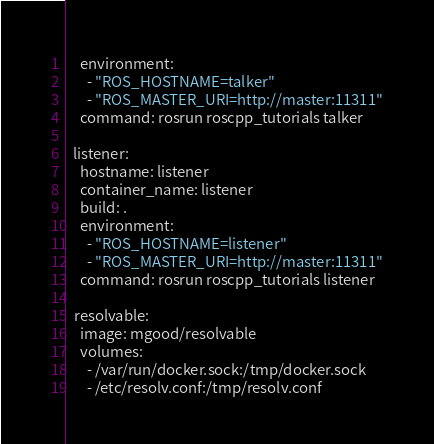Convert code to text. <code><loc_0><loc_0><loc_500><loc_500><_YAML_>    environment:
      - "ROS_HOSTNAME=talker"
      - "ROS_MASTER_URI=http://master:11311"
    command: rosrun roscpp_tutorials talker

  listener:
    hostname: listener
    container_name: listener
    build: .
    environment:
      - "ROS_HOSTNAME=listener"
      - "ROS_MASTER_URI=http://master:11311"
    command: rosrun roscpp_tutorials listener

  resolvable:
    image: mgood/resolvable
    volumes:
      - /var/run/docker.sock:/tmp/docker.sock
      - /etc/resolv.conf:/tmp/resolv.conf
</code> 